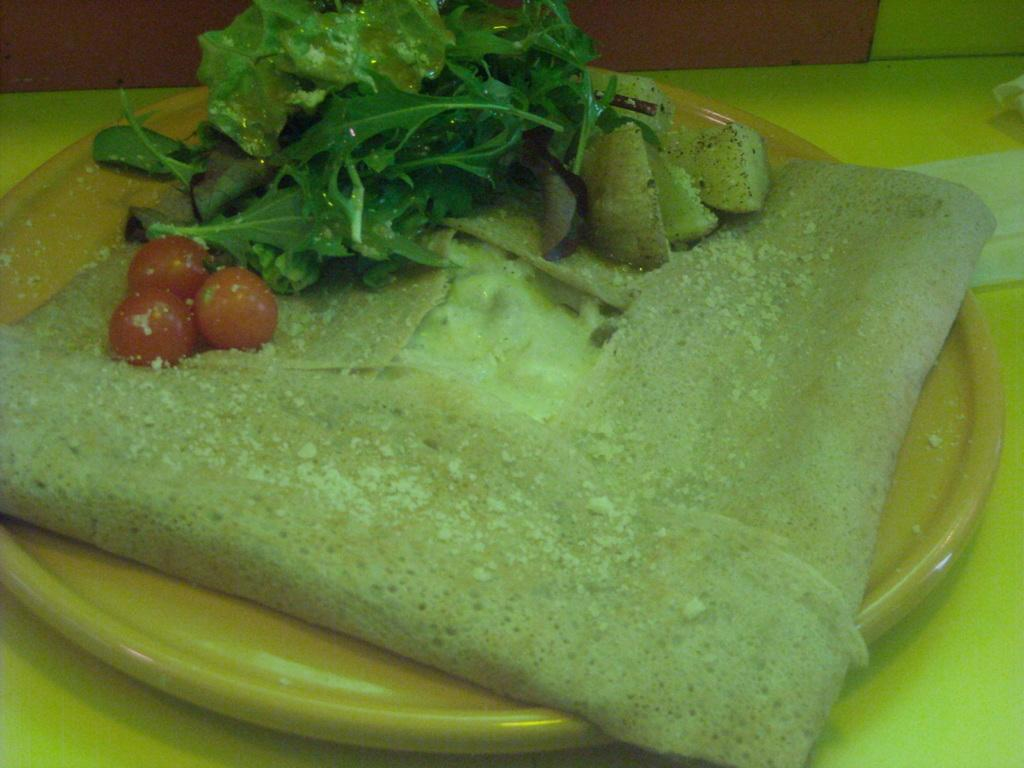What is placed on a plate in the image? There is food placed on a plate in the image. Where is the plate with food located? The plate with food is placed on a table. What language is spoken by the food on the plate in the image? The food on the plate does not speak a language, as it is an inanimate object. What type of lace can be seen on the tablecloth in the image? There is no tablecloth or lace visible in the image. 